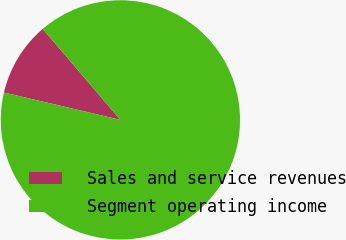Convert chart. <chart><loc_0><loc_0><loc_500><loc_500><pie_chart><fcel>Sales and service revenues<fcel>Segment operating income<nl><fcel>10.08%<fcel>89.92%<nl></chart> 